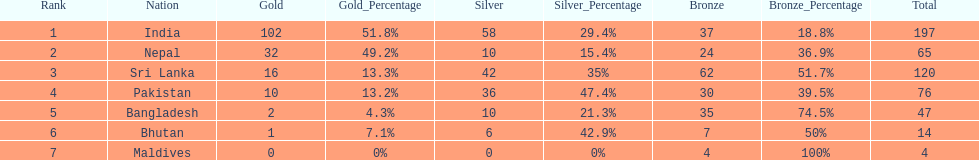Who has won the most bronze medals? Sri Lanka. 